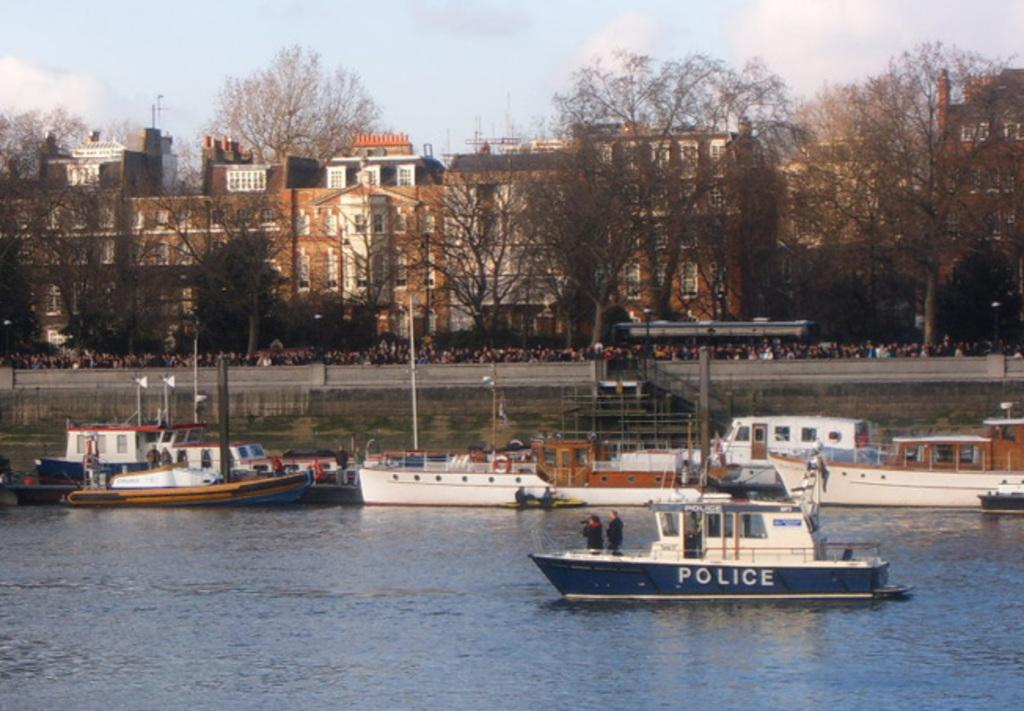What is located in the center of the image? There are boats in the center of the image. What is at the bottom of the image? There is water at the bottom of the image. What can be seen in the background of the image? There are buildings and trees in the background of the image. Can you tell me how many apples are floating in the water in the image? There are no apples present in the image; it features boats on water with buildings and trees in the background. What type of expansion is occurring in the image? There is no expansion occurring in the image; it depicts boats, water, buildings, and trees. 